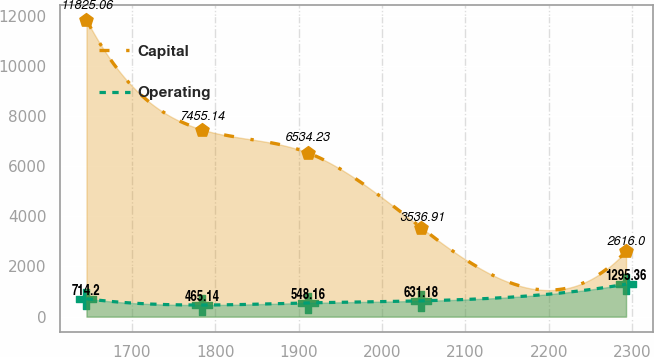Convert chart to OTSL. <chart><loc_0><loc_0><loc_500><loc_500><line_chart><ecel><fcel>Capital<fcel>Operating<nl><fcel>1645.71<fcel>11825.1<fcel>714.2<nl><fcel>1784.4<fcel>7455.14<fcel>465.14<nl><fcel>1910.99<fcel>6534.23<fcel>548.16<nl><fcel>2047.4<fcel>3536.91<fcel>631.18<nl><fcel>2292.69<fcel>2616<fcel>1295.36<nl></chart> 